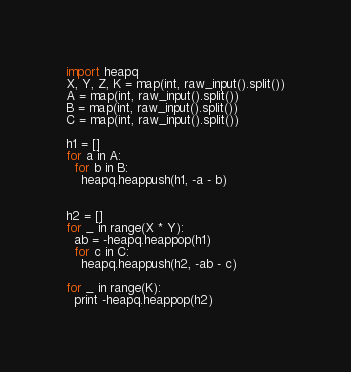Convert code to text. <code><loc_0><loc_0><loc_500><loc_500><_Python_>import heapq
X, Y, Z, K = map(int, raw_input().split())
A = map(int, raw_input().split())
B = map(int, raw_input().split())
C = map(int, raw_input().split())

h1 = []
for a in A:
  for b in B:
    heapq.heappush(h1, -a - b)


h2 = []
for _ in range(X * Y):
  ab = -heapq.heappop(h1)
  for c in C:
    heapq.heappush(h2, -ab - c)

for _ in range(K):
  print -heapq.heappop(h2)</code> 